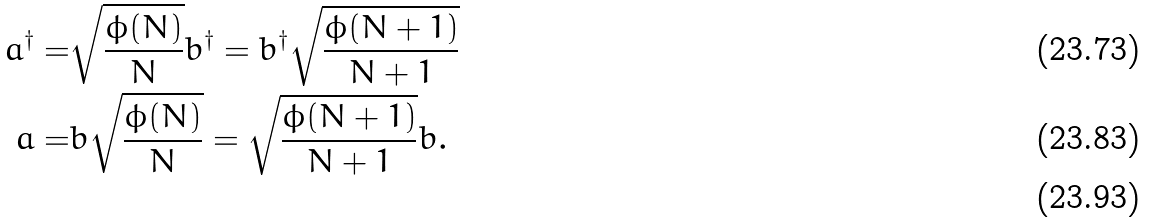<formula> <loc_0><loc_0><loc_500><loc_500>a ^ { \dagger } = & \sqrt { \frac { \phi ( N ) } { N } } b ^ { \dagger } = b ^ { \dagger } \sqrt { \frac { \phi ( N + 1 ) } { N + 1 } } \\ a = & b \sqrt { \frac { \phi ( N ) } { N } } = \sqrt { \frac { \phi ( N + 1 ) } { N + 1 } } b . \\</formula> 